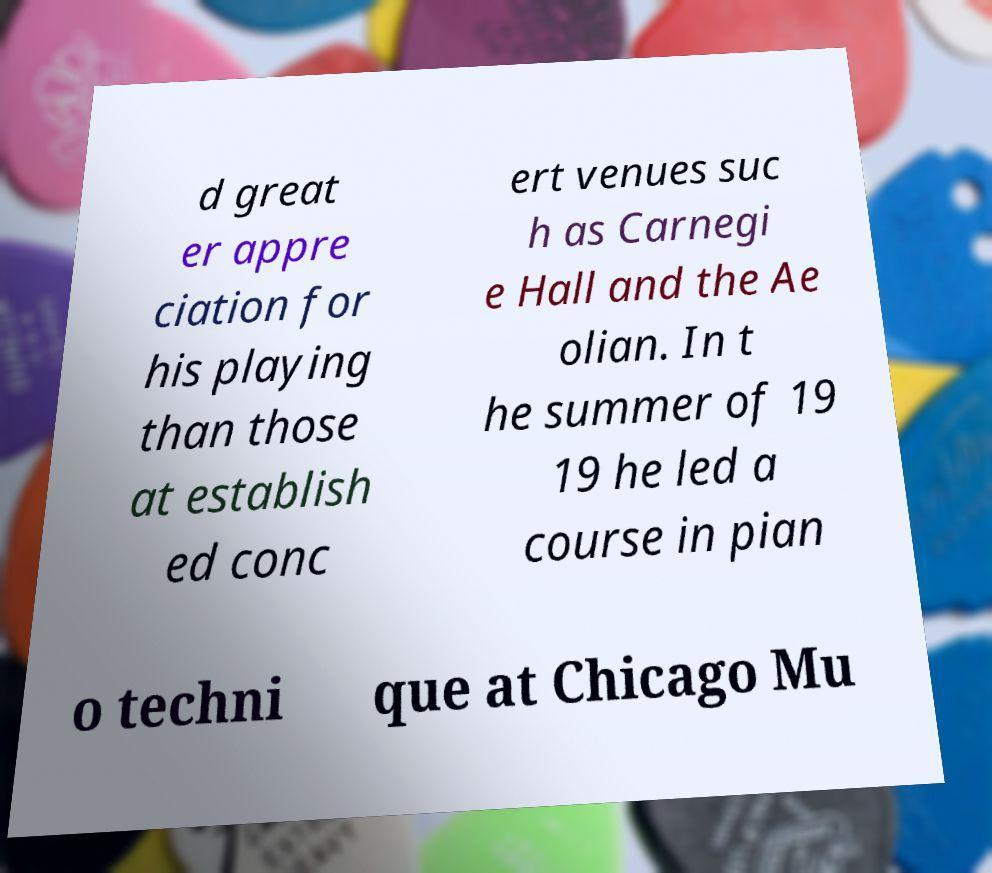For documentation purposes, I need the text within this image transcribed. Could you provide that? d great er appre ciation for his playing than those at establish ed conc ert venues suc h as Carnegi e Hall and the Ae olian. In t he summer of 19 19 he led a course in pian o techni que at Chicago Mu 